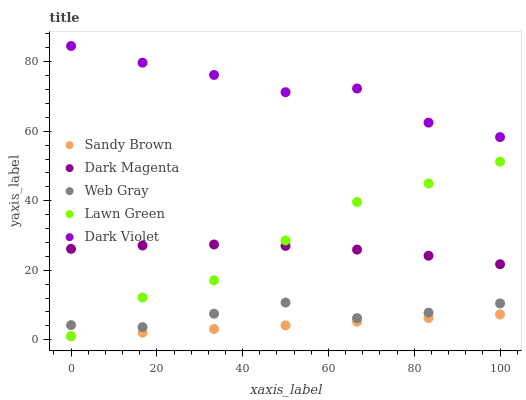Does Sandy Brown have the minimum area under the curve?
Answer yes or no. Yes. Does Dark Violet have the maximum area under the curve?
Answer yes or no. Yes. Does Web Gray have the minimum area under the curve?
Answer yes or no. No. Does Web Gray have the maximum area under the curve?
Answer yes or no. No. Is Sandy Brown the smoothest?
Answer yes or no. Yes. Is Dark Violet the roughest?
Answer yes or no. Yes. Is Web Gray the smoothest?
Answer yes or no. No. Is Web Gray the roughest?
Answer yes or no. No. Does Lawn Green have the lowest value?
Answer yes or no. Yes. Does Web Gray have the lowest value?
Answer yes or no. No. Does Dark Violet have the highest value?
Answer yes or no. Yes. Does Web Gray have the highest value?
Answer yes or no. No. Is Sandy Brown less than Dark Violet?
Answer yes or no. Yes. Is Web Gray greater than Sandy Brown?
Answer yes or no. Yes. Does Web Gray intersect Lawn Green?
Answer yes or no. Yes. Is Web Gray less than Lawn Green?
Answer yes or no. No. Is Web Gray greater than Lawn Green?
Answer yes or no. No. Does Sandy Brown intersect Dark Violet?
Answer yes or no. No. 